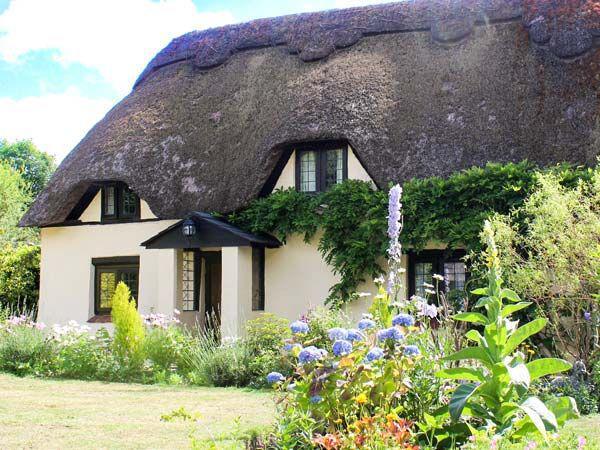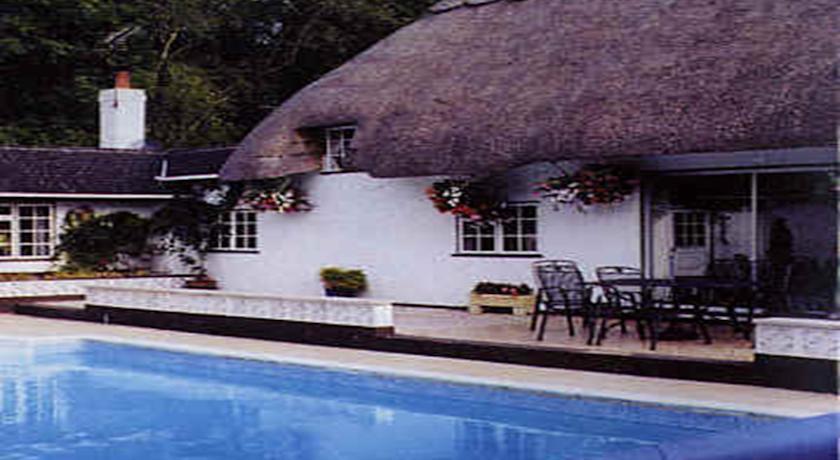The first image is the image on the left, the second image is the image on the right. Considering the images on both sides, is "Patio furniture is in front of a house." valid? Answer yes or no. Yes. The first image is the image on the left, the second image is the image on the right. For the images displayed, is the sentence "One of the houses has a swimming pool." factually correct? Answer yes or no. Yes. 